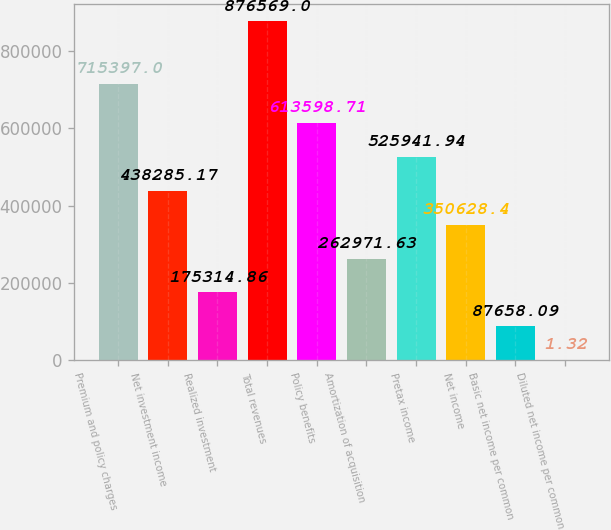<chart> <loc_0><loc_0><loc_500><loc_500><bar_chart><fcel>Premium and policy charges<fcel>Net investment income<fcel>Realized investment<fcel>Total revenues<fcel>Policy benefits<fcel>Amortization of acquisition<fcel>Pretax income<fcel>Net income<fcel>Basic net income per common<fcel>Diluted net income per common<nl><fcel>715397<fcel>438285<fcel>175315<fcel>876569<fcel>613599<fcel>262972<fcel>525942<fcel>350628<fcel>87658.1<fcel>1.32<nl></chart> 